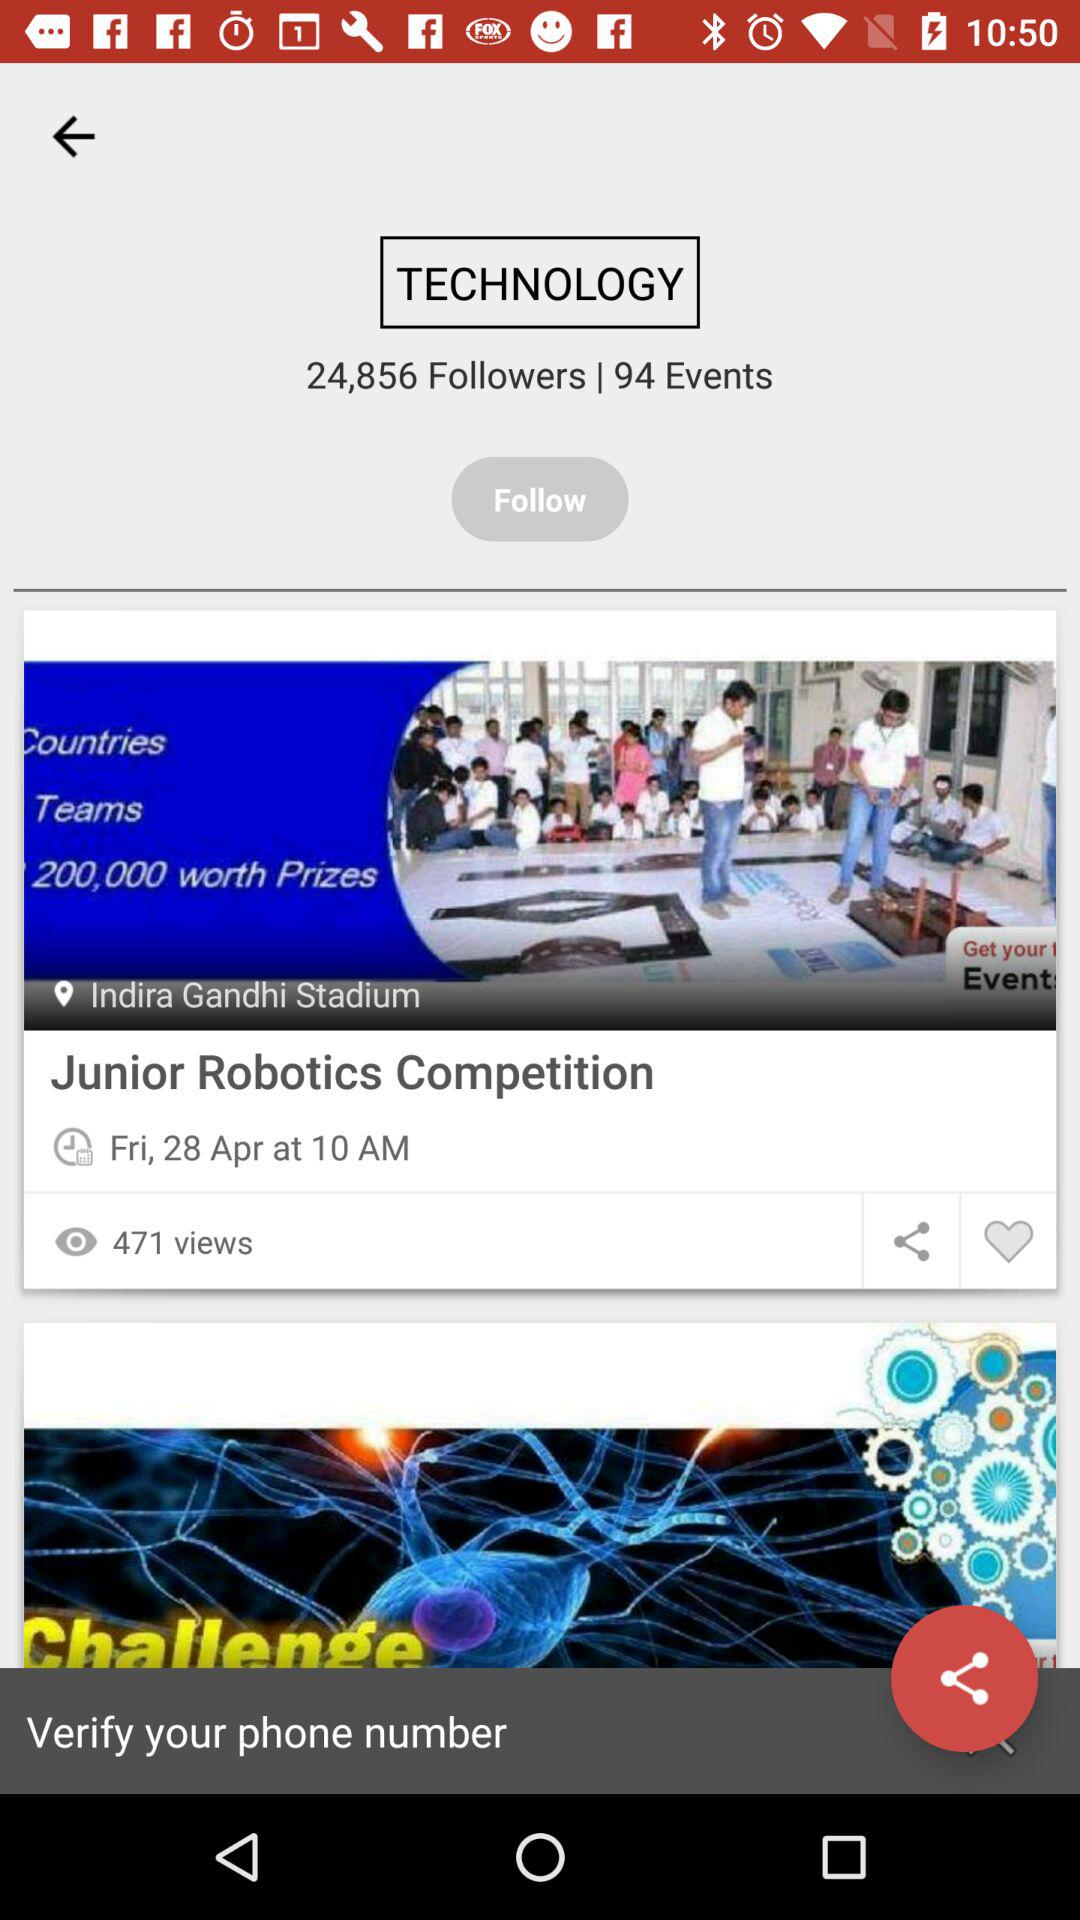How many events are there? There are 94 events. 